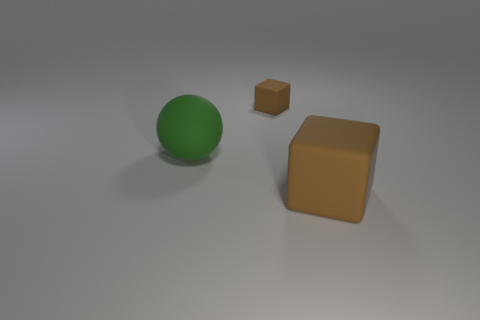What is the material of the big brown thing that is the same shape as the tiny brown rubber thing?
Your answer should be compact. Rubber. There is a tiny thing that is behind the brown matte thing in front of the green rubber ball; what is its color?
Your answer should be very brief. Brown. There is another cube that is the same material as the large brown block; what size is it?
Provide a succinct answer. Small. What number of big brown things have the same shape as the big green object?
Your answer should be very brief. 0. How many things are either big rubber balls that are on the left side of the big brown thing or brown matte cubes that are behind the green object?
Your answer should be very brief. 2. How many big rubber things are left of the matte block that is behind the big green thing?
Your answer should be very brief. 1. There is a brown rubber thing that is to the right of the small brown cube; does it have the same shape as the tiny thing to the right of the green object?
Provide a succinct answer. Yes. Are there any brown objects that have the same material as the small brown cube?
Make the answer very short. Yes. What number of rubber things are either brown blocks or big brown things?
Offer a very short reply. 2. What shape is the rubber thing that is to the left of the rubber block behind the green ball?
Keep it short and to the point. Sphere. 